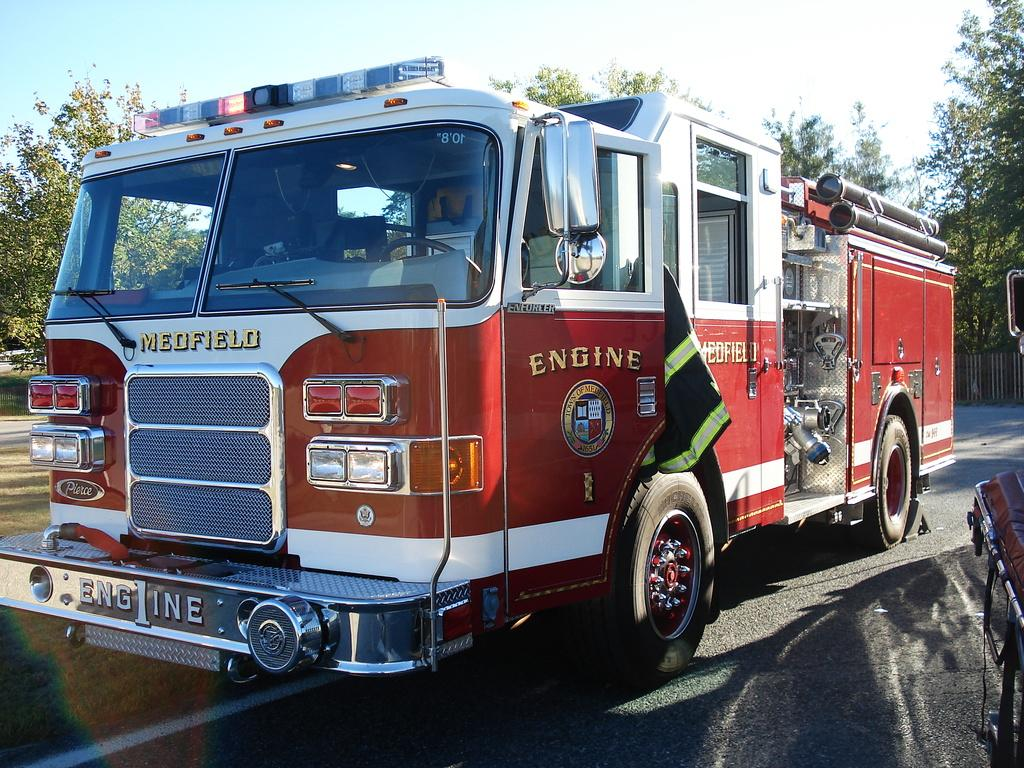What is the main subject of the image? There is a vehicle on the road in the image. Where is the vehicle located in the image? The vehicle is in the middle of the image. What can be seen in the background of the image? There are trees in the background of the image. What is visible at the top of the image? The sky is visible at the top of the image. Reasoning: Let' Let's think step by step in order to produce the conversation. We start by identifying the main subject of the image, which is the vehicle on the road. Next, we describe the location of the vehicle within the image, noting that it is in the middle. Then, we observe the background and the sky, mentioning the trees and the visible sky. Absurd Question/Answer: How many tickets are attached to the wall in the image? There is no wall or tickets present in the image. What angle is the vehicle positioned at in the image? The image does not provide information about the angle at which the vehicle is positioned. 